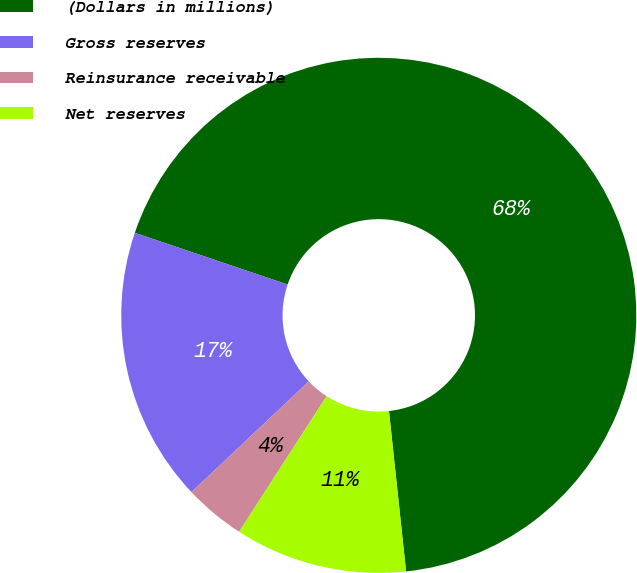Convert chart. <chart><loc_0><loc_0><loc_500><loc_500><pie_chart><fcel>(Dollars in millions)<fcel>Gross reserves<fcel>Reinsurance receivable<fcel>Net reserves<nl><fcel>68.12%<fcel>17.23%<fcel>3.84%<fcel>10.81%<nl></chart> 